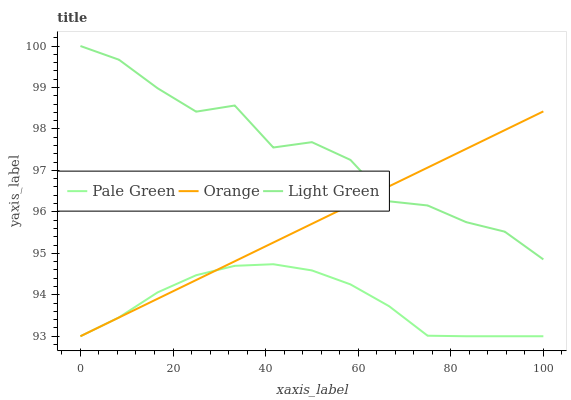Does Pale Green have the minimum area under the curve?
Answer yes or no. Yes. Does Light Green have the maximum area under the curve?
Answer yes or no. Yes. Does Light Green have the minimum area under the curve?
Answer yes or no. No. Does Pale Green have the maximum area under the curve?
Answer yes or no. No. Is Orange the smoothest?
Answer yes or no. Yes. Is Light Green the roughest?
Answer yes or no. Yes. Is Pale Green the smoothest?
Answer yes or no. No. Is Pale Green the roughest?
Answer yes or no. No. Does Orange have the lowest value?
Answer yes or no. Yes. Does Light Green have the lowest value?
Answer yes or no. No. Does Light Green have the highest value?
Answer yes or no. Yes. Does Pale Green have the highest value?
Answer yes or no. No. Is Pale Green less than Light Green?
Answer yes or no. Yes. Is Light Green greater than Pale Green?
Answer yes or no. Yes. Does Orange intersect Light Green?
Answer yes or no. Yes. Is Orange less than Light Green?
Answer yes or no. No. Is Orange greater than Light Green?
Answer yes or no. No. Does Pale Green intersect Light Green?
Answer yes or no. No. 